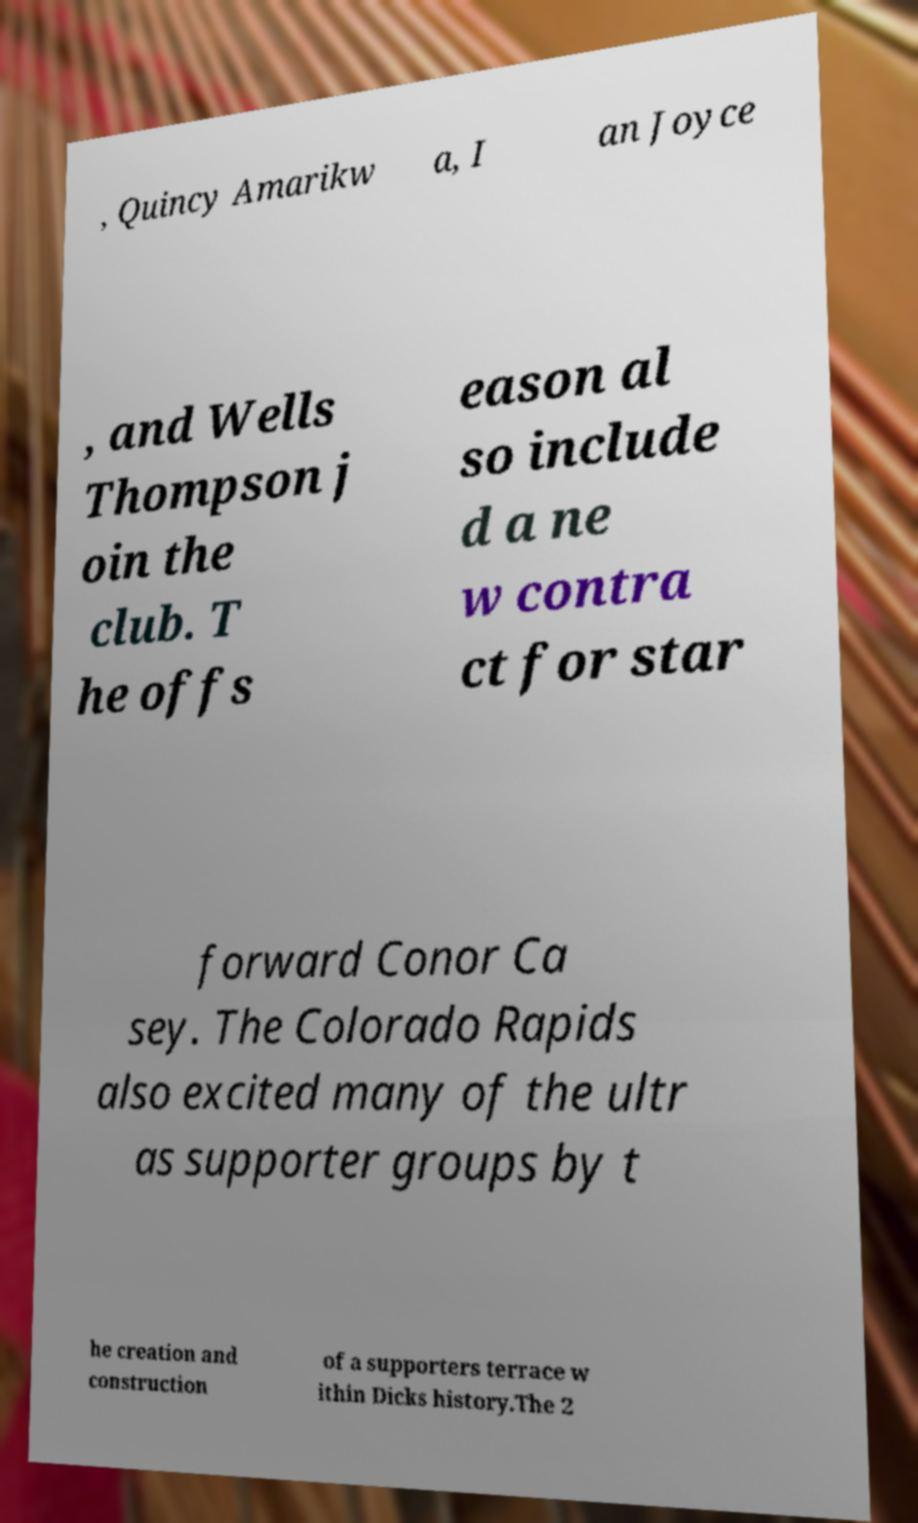Please read and relay the text visible in this image. What does it say? , Quincy Amarikw a, I an Joyce , and Wells Thompson j oin the club. T he offs eason al so include d a ne w contra ct for star forward Conor Ca sey. The Colorado Rapids also excited many of the ultr as supporter groups by t he creation and construction of a supporters terrace w ithin Dicks history.The 2 